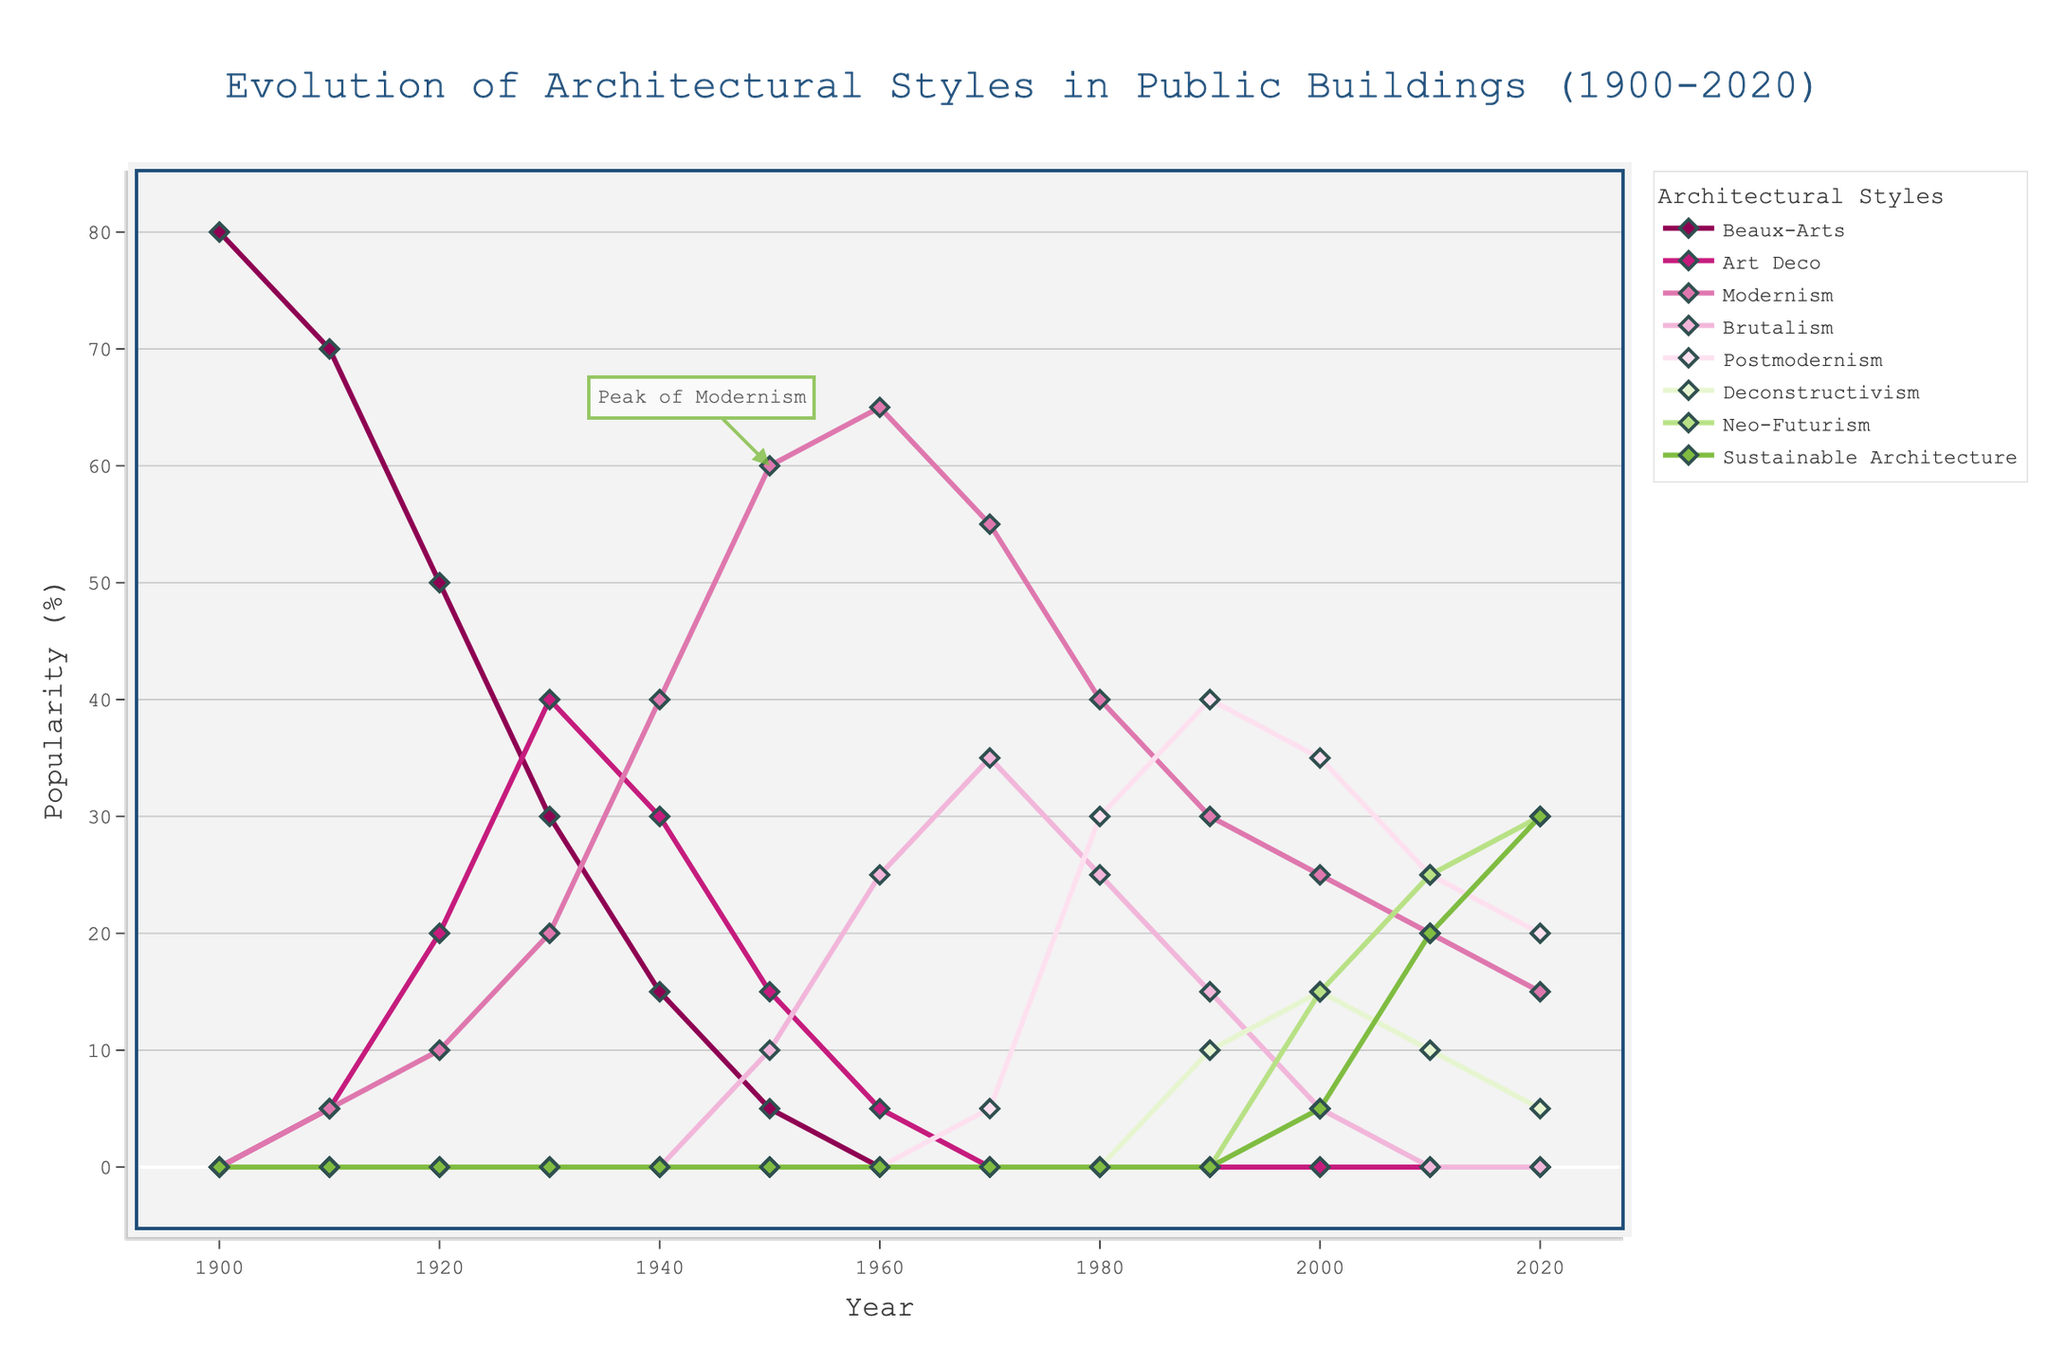What percentage of public buildings featured Modernism in the year 1950? Find the year 1950 on the x-axis and follow the line up to where it intersects with the Modernism trend. The corresponding y-value shows the percentage
Answer: 60% Which architectural style had the highest popularity in 1910? Look at the year 1910 and identify which trend line reaches the highest point. Beaux-Arts was highest at this point
Answer: Beaux-Arts Comparing 1930 to 1940, by how much did the popularity of Art Deco change? At 1930, Art Deco is at 40%, and in 1940, it is at 30%. Subtract 30 from 40 to find the difference
Answer: -10% At which year did Brutalism reach its peak popularity, and what was the percentage? Observe the trend of Brutalism and find the year where it is at its highest point on the y-axis, which is 1970 at 35%
Answer: 1970, 35% By how much did the popularity of Neo-Futurism change from 2000 to 2020? Find the values at 2000 (15%) and 2020 (30%). Subtract 15 from 30 to determine the increase
Answer: +15% What architectural style is represented by the fourth color in the sequence, and how can you identify it visually? Count lines starting from the topmost line. The fourth color represents Brutalism, identified by its dark green color and line style
Answer: Brutalism Which year saw the peak of Postmodernism's popularity? Look for the highest value/peak in the Postmodernism trend line, which is 1990 at 40%
Answer: 1990 From 1910 to 1930, which architectural style had a constant rise in popularity? Look at the trend lines for each style from 1910 to 1930. Art Deco rises from 5% to 40% consistently
Answer: Art Deco What percentage of public buildings featured Sustainable Architecture in 2020, and how does this compare to Art Deco in 1920? Sustainable Architecture reached 30% in 2020, whereas Art Deco was at 20% in 1920, showing a 10% higher popularity for Sustainable Architecture
Answer: Sustainable Architecture is 10% higher in 2020 Calculate the average popularity of Postmodernism from 1980 to 2020. Add the values at 1980 (30%), 1990 (40%), 2000 (35%), 2010 (25%), and 2020 (20%). Divide the sum by the number of years (5). (30 + 40 + 35 + 25 + 20) / 5 = 30%
Answer: 30% 